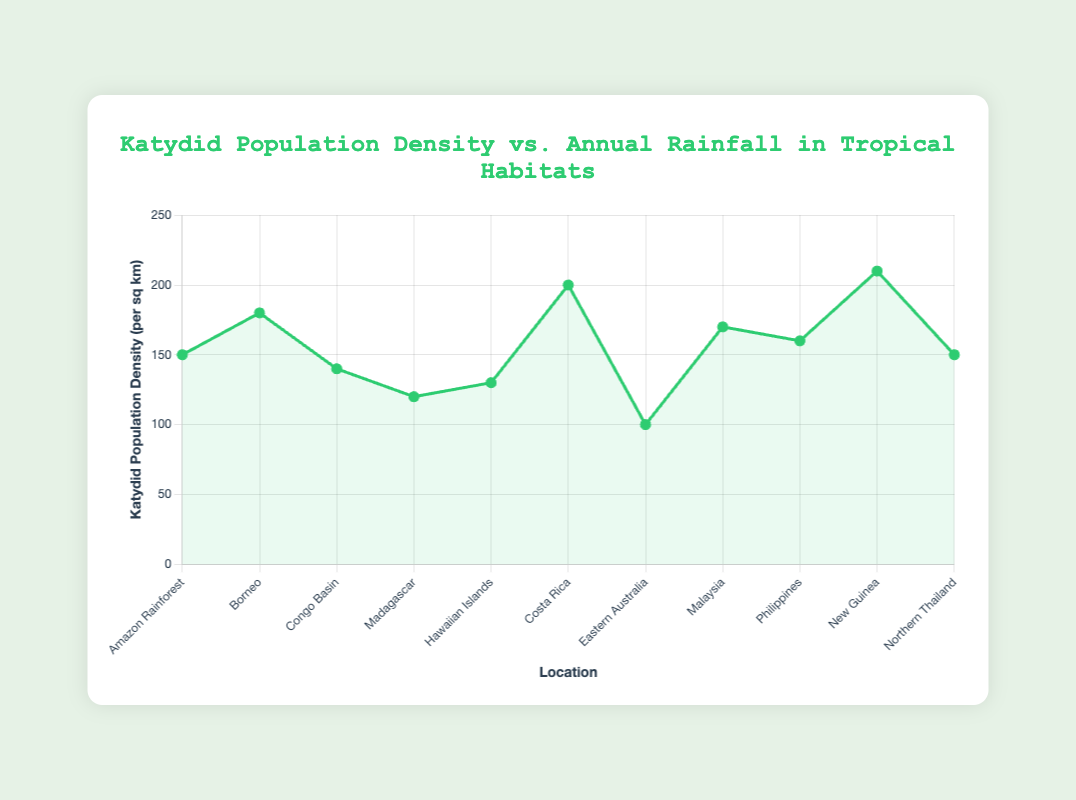What is the general trend between annual rainfall and katydid population density? The line plot shows that as the annual rainfall increases, the katydid population density tends to also increase. This trend is visible from the rising values in the data points as rainfall increases.
Answer: Increase Which location has the highest katydid population density? By examining the line plot, we can see that the data point representing "New Guinea" has the highest katydid population density.
Answer: New Guinea Does the katydid population density always increase with an increase in annual rainfall? Although there is a general trend of increase, there are locations such as "Congo Basin" with lower population density (140) compared to "Amazon Rainforest" (150) despite having lesser annual rainfall (2000 mm vs. 2200 mm). This indicates the relationship is not perfectly linear.
Answer: No Which location has the lowest annual rainfall and does it correlate with its katydid population density? "Eastern Australia" has the lowest annual rainfall (1400 mm) and a lower katydid population density (100 per sq km) compared to other locations. This correlation fits the general trend of increasing population density with rainfall.
Answer: Eastern Australia; Yes If considering the group with annual rainfall between 2000-2500 mm, what is the average katydid population density? The locations with annual rainfall between 2000 to 2500 mm are "Amazon Rainforest" (150), "Congo Basin" (140), "Malaysia" (170), "Philippines" (160), and "Northern Thailand" (150). The average is calculated as (150 + 140 + 170 + 160 + 150) / 5 = 154
Answer: 154 Compare the katydid population density between locations with annual rainfall of 1400 mm and 1600 mm. The locations are "Eastern Australia" with 1400 mm rainfall and a population density of 100, and "Madagascar" with 1600 mm rainfall and a population density of 120. Hence, katydid population density is higher at 1600 mm rainfall.
Answer: Madagascar is higher Which locations have the same katydid population density, and what is it? "Amazon Rainforest" and "Northern Thailand" both have a katydid population density of 150 per sq km, as observed from the line plot.
Answer: Amazon Rainforest and Northern Thailand; 150 Calculate the total katydid population density for all the locations combined. Adding all the katydid population densities: 150 (Amazon Rainforest) + 180 (Borneo) + 140 (Congo Basin) + 120 (Madagascar) + 130 (Hawaiian Islands) + 200 (Costa Rica) + 100 (Eastern Australia) + 170 (Malaysia) + 160 (Philippines) + 210 (New Guinea) + 150 (Northern Thailand) = 1710
Answer: 1710 What is the difference in katydid population density between the location with the highest population density and the one with the lowest? "New Guinea" has the highest population density of 210 per sq km, and "Eastern Australia" has the lowest at 100 per sq km. The difference is 210 - 100 = 110.
Answer: 110 